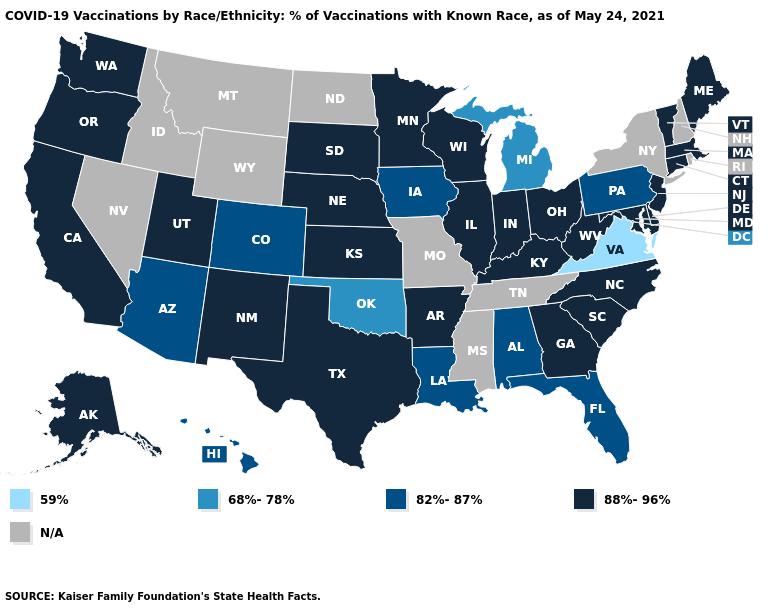What is the value of Texas?
Concise answer only. 88%-96%. What is the lowest value in the West?
Answer briefly. 82%-87%. Name the states that have a value in the range 68%-78%?
Be succinct. Michigan, Oklahoma. Does the first symbol in the legend represent the smallest category?
Concise answer only. Yes. What is the value of New Hampshire?
Write a very short answer. N/A. Does Arizona have the highest value in the West?
Be succinct. No. Which states hav the highest value in the MidWest?
Keep it brief. Illinois, Indiana, Kansas, Minnesota, Nebraska, Ohio, South Dakota, Wisconsin. Name the states that have a value in the range 88%-96%?
Keep it brief. Alaska, Arkansas, California, Connecticut, Delaware, Georgia, Illinois, Indiana, Kansas, Kentucky, Maine, Maryland, Massachusetts, Minnesota, Nebraska, New Jersey, New Mexico, North Carolina, Ohio, Oregon, South Carolina, South Dakota, Texas, Utah, Vermont, Washington, West Virginia, Wisconsin. What is the lowest value in the USA?
Be succinct. 59%. What is the highest value in the USA?
Concise answer only. 88%-96%. Does the first symbol in the legend represent the smallest category?
Keep it brief. Yes. Among the states that border Utah , does New Mexico have the lowest value?
Answer briefly. No. What is the lowest value in the USA?
Quick response, please. 59%. 